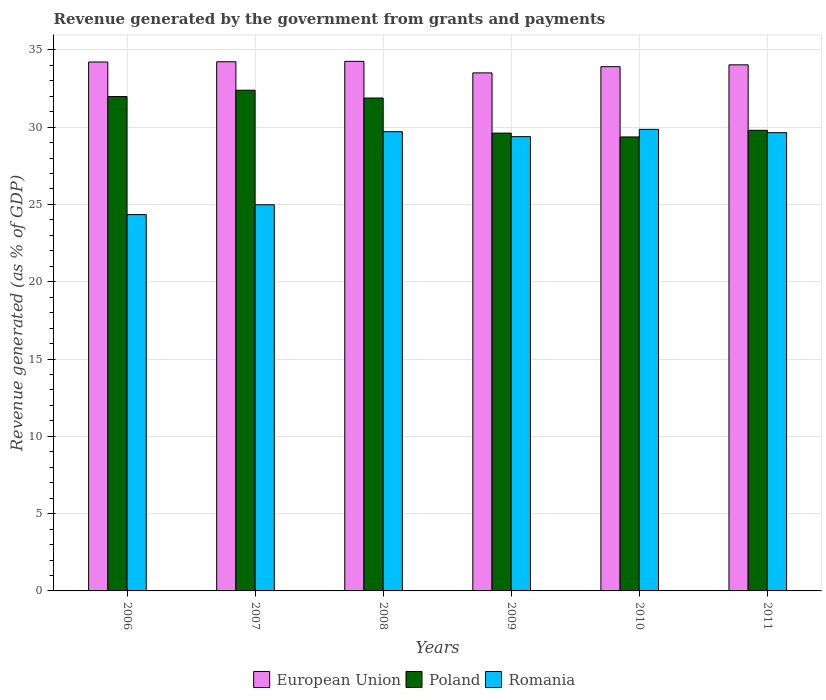Are the number of bars per tick equal to the number of legend labels?
Offer a very short reply. Yes. How many bars are there on the 3rd tick from the left?
Your response must be concise. 3. How many bars are there on the 4th tick from the right?
Give a very brief answer. 3. In how many cases, is the number of bars for a given year not equal to the number of legend labels?
Keep it short and to the point. 0. What is the revenue generated by the government in Romania in 2011?
Offer a very short reply. 29.64. Across all years, what is the maximum revenue generated by the government in Poland?
Your answer should be compact. 32.39. Across all years, what is the minimum revenue generated by the government in Romania?
Offer a terse response. 24.34. In which year was the revenue generated by the government in Romania minimum?
Provide a short and direct response. 2006. What is the total revenue generated by the government in Poland in the graph?
Offer a very short reply. 185.02. What is the difference between the revenue generated by the government in Romania in 2006 and that in 2009?
Your answer should be compact. -5.04. What is the difference between the revenue generated by the government in Romania in 2010 and the revenue generated by the government in Poland in 2009?
Offer a very short reply. 0.24. What is the average revenue generated by the government in European Union per year?
Offer a very short reply. 34.02. In the year 2009, what is the difference between the revenue generated by the government in Romania and revenue generated by the government in European Union?
Ensure brevity in your answer.  -4.13. In how many years, is the revenue generated by the government in Poland greater than 32 %?
Your answer should be very brief. 1. What is the ratio of the revenue generated by the government in European Union in 2009 to that in 2011?
Offer a very short reply. 0.98. What is the difference between the highest and the second highest revenue generated by the government in Romania?
Your answer should be very brief. 0.15. What is the difference between the highest and the lowest revenue generated by the government in Poland?
Offer a very short reply. 3.02. In how many years, is the revenue generated by the government in Romania greater than the average revenue generated by the government in Romania taken over all years?
Ensure brevity in your answer.  4. What does the 3rd bar from the left in 2006 represents?
Your response must be concise. Romania. Are all the bars in the graph horizontal?
Your answer should be very brief. No. What is the difference between two consecutive major ticks on the Y-axis?
Offer a terse response. 5. Does the graph contain any zero values?
Your answer should be very brief. No. Does the graph contain grids?
Your answer should be very brief. Yes. What is the title of the graph?
Offer a very short reply. Revenue generated by the government from grants and payments. What is the label or title of the Y-axis?
Ensure brevity in your answer.  Revenue generated (as % of GDP). What is the Revenue generated (as % of GDP) of European Union in 2006?
Provide a short and direct response. 34.21. What is the Revenue generated (as % of GDP) of Poland in 2006?
Offer a terse response. 31.98. What is the Revenue generated (as % of GDP) in Romania in 2006?
Your answer should be compact. 24.34. What is the Revenue generated (as % of GDP) of European Union in 2007?
Keep it short and to the point. 34.23. What is the Revenue generated (as % of GDP) of Poland in 2007?
Make the answer very short. 32.39. What is the Revenue generated (as % of GDP) in Romania in 2007?
Offer a very short reply. 24.98. What is the Revenue generated (as % of GDP) in European Union in 2008?
Provide a succinct answer. 34.25. What is the Revenue generated (as % of GDP) of Poland in 2008?
Keep it short and to the point. 31.88. What is the Revenue generated (as % of GDP) of Romania in 2008?
Offer a very short reply. 29.7. What is the Revenue generated (as % of GDP) of European Union in 2009?
Make the answer very short. 33.51. What is the Revenue generated (as % of GDP) of Poland in 2009?
Provide a succinct answer. 29.61. What is the Revenue generated (as % of GDP) in Romania in 2009?
Your response must be concise. 29.38. What is the Revenue generated (as % of GDP) in European Union in 2010?
Keep it short and to the point. 33.91. What is the Revenue generated (as % of GDP) of Poland in 2010?
Your answer should be very brief. 29.36. What is the Revenue generated (as % of GDP) of Romania in 2010?
Offer a terse response. 29.86. What is the Revenue generated (as % of GDP) in European Union in 2011?
Make the answer very short. 34.03. What is the Revenue generated (as % of GDP) in Poland in 2011?
Your answer should be very brief. 29.79. What is the Revenue generated (as % of GDP) of Romania in 2011?
Provide a succinct answer. 29.64. Across all years, what is the maximum Revenue generated (as % of GDP) in European Union?
Make the answer very short. 34.25. Across all years, what is the maximum Revenue generated (as % of GDP) in Poland?
Your response must be concise. 32.39. Across all years, what is the maximum Revenue generated (as % of GDP) in Romania?
Provide a short and direct response. 29.86. Across all years, what is the minimum Revenue generated (as % of GDP) of European Union?
Offer a terse response. 33.51. Across all years, what is the minimum Revenue generated (as % of GDP) in Poland?
Provide a short and direct response. 29.36. Across all years, what is the minimum Revenue generated (as % of GDP) of Romania?
Your answer should be compact. 24.34. What is the total Revenue generated (as % of GDP) in European Union in the graph?
Keep it short and to the point. 204.14. What is the total Revenue generated (as % of GDP) in Poland in the graph?
Provide a succinct answer. 185.02. What is the total Revenue generated (as % of GDP) in Romania in the graph?
Offer a terse response. 167.9. What is the difference between the Revenue generated (as % of GDP) of European Union in 2006 and that in 2007?
Provide a short and direct response. -0.02. What is the difference between the Revenue generated (as % of GDP) in Poland in 2006 and that in 2007?
Make the answer very short. -0.41. What is the difference between the Revenue generated (as % of GDP) of Romania in 2006 and that in 2007?
Provide a succinct answer. -0.64. What is the difference between the Revenue generated (as % of GDP) in European Union in 2006 and that in 2008?
Your response must be concise. -0.04. What is the difference between the Revenue generated (as % of GDP) of Poland in 2006 and that in 2008?
Offer a very short reply. 0.1. What is the difference between the Revenue generated (as % of GDP) in Romania in 2006 and that in 2008?
Your response must be concise. -5.36. What is the difference between the Revenue generated (as % of GDP) in European Union in 2006 and that in 2009?
Provide a succinct answer. 0.7. What is the difference between the Revenue generated (as % of GDP) of Poland in 2006 and that in 2009?
Offer a very short reply. 2.36. What is the difference between the Revenue generated (as % of GDP) of Romania in 2006 and that in 2009?
Your response must be concise. -5.04. What is the difference between the Revenue generated (as % of GDP) in European Union in 2006 and that in 2010?
Ensure brevity in your answer.  0.3. What is the difference between the Revenue generated (as % of GDP) of Poland in 2006 and that in 2010?
Give a very brief answer. 2.61. What is the difference between the Revenue generated (as % of GDP) in Romania in 2006 and that in 2010?
Your answer should be very brief. -5.51. What is the difference between the Revenue generated (as % of GDP) of European Union in 2006 and that in 2011?
Ensure brevity in your answer.  0.18. What is the difference between the Revenue generated (as % of GDP) in Poland in 2006 and that in 2011?
Give a very brief answer. 2.18. What is the difference between the Revenue generated (as % of GDP) of Romania in 2006 and that in 2011?
Provide a succinct answer. -5.3. What is the difference between the Revenue generated (as % of GDP) of European Union in 2007 and that in 2008?
Offer a terse response. -0.03. What is the difference between the Revenue generated (as % of GDP) in Poland in 2007 and that in 2008?
Your answer should be compact. 0.51. What is the difference between the Revenue generated (as % of GDP) in Romania in 2007 and that in 2008?
Offer a very short reply. -4.72. What is the difference between the Revenue generated (as % of GDP) of European Union in 2007 and that in 2009?
Offer a very short reply. 0.72. What is the difference between the Revenue generated (as % of GDP) of Poland in 2007 and that in 2009?
Make the answer very short. 2.78. What is the difference between the Revenue generated (as % of GDP) in Romania in 2007 and that in 2009?
Ensure brevity in your answer.  -4.4. What is the difference between the Revenue generated (as % of GDP) of European Union in 2007 and that in 2010?
Offer a very short reply. 0.32. What is the difference between the Revenue generated (as % of GDP) in Poland in 2007 and that in 2010?
Provide a succinct answer. 3.02. What is the difference between the Revenue generated (as % of GDP) in Romania in 2007 and that in 2010?
Provide a short and direct response. -4.88. What is the difference between the Revenue generated (as % of GDP) in European Union in 2007 and that in 2011?
Offer a terse response. 0.2. What is the difference between the Revenue generated (as % of GDP) of Poland in 2007 and that in 2011?
Provide a short and direct response. 2.59. What is the difference between the Revenue generated (as % of GDP) in Romania in 2007 and that in 2011?
Your response must be concise. -4.66. What is the difference between the Revenue generated (as % of GDP) in European Union in 2008 and that in 2009?
Your response must be concise. 0.75. What is the difference between the Revenue generated (as % of GDP) of Poland in 2008 and that in 2009?
Your answer should be very brief. 2.27. What is the difference between the Revenue generated (as % of GDP) of Romania in 2008 and that in 2009?
Your answer should be very brief. 0.32. What is the difference between the Revenue generated (as % of GDP) of European Union in 2008 and that in 2010?
Provide a short and direct response. 0.34. What is the difference between the Revenue generated (as % of GDP) of Poland in 2008 and that in 2010?
Provide a succinct answer. 2.52. What is the difference between the Revenue generated (as % of GDP) in Romania in 2008 and that in 2010?
Your response must be concise. -0.15. What is the difference between the Revenue generated (as % of GDP) of European Union in 2008 and that in 2011?
Keep it short and to the point. 0.23. What is the difference between the Revenue generated (as % of GDP) in Poland in 2008 and that in 2011?
Keep it short and to the point. 2.09. What is the difference between the Revenue generated (as % of GDP) in Romania in 2008 and that in 2011?
Provide a short and direct response. 0.06. What is the difference between the Revenue generated (as % of GDP) of European Union in 2009 and that in 2010?
Offer a very short reply. -0.4. What is the difference between the Revenue generated (as % of GDP) of Poland in 2009 and that in 2010?
Give a very brief answer. 0.25. What is the difference between the Revenue generated (as % of GDP) in Romania in 2009 and that in 2010?
Provide a succinct answer. -0.47. What is the difference between the Revenue generated (as % of GDP) in European Union in 2009 and that in 2011?
Provide a succinct answer. -0.52. What is the difference between the Revenue generated (as % of GDP) in Poland in 2009 and that in 2011?
Offer a terse response. -0.18. What is the difference between the Revenue generated (as % of GDP) of Romania in 2009 and that in 2011?
Ensure brevity in your answer.  -0.26. What is the difference between the Revenue generated (as % of GDP) in European Union in 2010 and that in 2011?
Ensure brevity in your answer.  -0.12. What is the difference between the Revenue generated (as % of GDP) in Poland in 2010 and that in 2011?
Your response must be concise. -0.43. What is the difference between the Revenue generated (as % of GDP) of Romania in 2010 and that in 2011?
Give a very brief answer. 0.21. What is the difference between the Revenue generated (as % of GDP) in European Union in 2006 and the Revenue generated (as % of GDP) in Poland in 2007?
Offer a very short reply. 1.82. What is the difference between the Revenue generated (as % of GDP) of European Union in 2006 and the Revenue generated (as % of GDP) of Romania in 2007?
Keep it short and to the point. 9.23. What is the difference between the Revenue generated (as % of GDP) in Poland in 2006 and the Revenue generated (as % of GDP) in Romania in 2007?
Offer a terse response. 7. What is the difference between the Revenue generated (as % of GDP) in European Union in 2006 and the Revenue generated (as % of GDP) in Poland in 2008?
Offer a terse response. 2.33. What is the difference between the Revenue generated (as % of GDP) in European Union in 2006 and the Revenue generated (as % of GDP) in Romania in 2008?
Your answer should be compact. 4.51. What is the difference between the Revenue generated (as % of GDP) of Poland in 2006 and the Revenue generated (as % of GDP) of Romania in 2008?
Offer a very short reply. 2.27. What is the difference between the Revenue generated (as % of GDP) in European Union in 2006 and the Revenue generated (as % of GDP) in Poland in 2009?
Offer a very short reply. 4.6. What is the difference between the Revenue generated (as % of GDP) of European Union in 2006 and the Revenue generated (as % of GDP) of Romania in 2009?
Your answer should be very brief. 4.83. What is the difference between the Revenue generated (as % of GDP) in Poland in 2006 and the Revenue generated (as % of GDP) in Romania in 2009?
Offer a terse response. 2.59. What is the difference between the Revenue generated (as % of GDP) in European Union in 2006 and the Revenue generated (as % of GDP) in Poland in 2010?
Provide a succinct answer. 4.85. What is the difference between the Revenue generated (as % of GDP) in European Union in 2006 and the Revenue generated (as % of GDP) in Romania in 2010?
Your answer should be compact. 4.36. What is the difference between the Revenue generated (as % of GDP) in Poland in 2006 and the Revenue generated (as % of GDP) in Romania in 2010?
Make the answer very short. 2.12. What is the difference between the Revenue generated (as % of GDP) of European Union in 2006 and the Revenue generated (as % of GDP) of Poland in 2011?
Keep it short and to the point. 4.42. What is the difference between the Revenue generated (as % of GDP) of European Union in 2006 and the Revenue generated (as % of GDP) of Romania in 2011?
Your response must be concise. 4.57. What is the difference between the Revenue generated (as % of GDP) in Poland in 2006 and the Revenue generated (as % of GDP) in Romania in 2011?
Your response must be concise. 2.34. What is the difference between the Revenue generated (as % of GDP) of European Union in 2007 and the Revenue generated (as % of GDP) of Poland in 2008?
Keep it short and to the point. 2.35. What is the difference between the Revenue generated (as % of GDP) of European Union in 2007 and the Revenue generated (as % of GDP) of Romania in 2008?
Provide a succinct answer. 4.53. What is the difference between the Revenue generated (as % of GDP) in Poland in 2007 and the Revenue generated (as % of GDP) in Romania in 2008?
Provide a short and direct response. 2.69. What is the difference between the Revenue generated (as % of GDP) in European Union in 2007 and the Revenue generated (as % of GDP) in Poland in 2009?
Make the answer very short. 4.62. What is the difference between the Revenue generated (as % of GDP) in European Union in 2007 and the Revenue generated (as % of GDP) in Romania in 2009?
Provide a succinct answer. 4.85. What is the difference between the Revenue generated (as % of GDP) of Poland in 2007 and the Revenue generated (as % of GDP) of Romania in 2009?
Give a very brief answer. 3.01. What is the difference between the Revenue generated (as % of GDP) of European Union in 2007 and the Revenue generated (as % of GDP) of Poland in 2010?
Your answer should be compact. 4.86. What is the difference between the Revenue generated (as % of GDP) of European Union in 2007 and the Revenue generated (as % of GDP) of Romania in 2010?
Make the answer very short. 4.37. What is the difference between the Revenue generated (as % of GDP) in Poland in 2007 and the Revenue generated (as % of GDP) in Romania in 2010?
Provide a succinct answer. 2.53. What is the difference between the Revenue generated (as % of GDP) in European Union in 2007 and the Revenue generated (as % of GDP) in Poland in 2011?
Keep it short and to the point. 4.43. What is the difference between the Revenue generated (as % of GDP) in European Union in 2007 and the Revenue generated (as % of GDP) in Romania in 2011?
Offer a very short reply. 4.59. What is the difference between the Revenue generated (as % of GDP) of Poland in 2007 and the Revenue generated (as % of GDP) of Romania in 2011?
Your answer should be compact. 2.75. What is the difference between the Revenue generated (as % of GDP) of European Union in 2008 and the Revenue generated (as % of GDP) of Poland in 2009?
Provide a short and direct response. 4.64. What is the difference between the Revenue generated (as % of GDP) of European Union in 2008 and the Revenue generated (as % of GDP) of Romania in 2009?
Offer a very short reply. 4.87. What is the difference between the Revenue generated (as % of GDP) in Poland in 2008 and the Revenue generated (as % of GDP) in Romania in 2009?
Provide a short and direct response. 2.5. What is the difference between the Revenue generated (as % of GDP) of European Union in 2008 and the Revenue generated (as % of GDP) of Poland in 2010?
Ensure brevity in your answer.  4.89. What is the difference between the Revenue generated (as % of GDP) of European Union in 2008 and the Revenue generated (as % of GDP) of Romania in 2010?
Make the answer very short. 4.4. What is the difference between the Revenue generated (as % of GDP) in Poland in 2008 and the Revenue generated (as % of GDP) in Romania in 2010?
Keep it short and to the point. 2.03. What is the difference between the Revenue generated (as % of GDP) of European Union in 2008 and the Revenue generated (as % of GDP) of Poland in 2011?
Provide a short and direct response. 4.46. What is the difference between the Revenue generated (as % of GDP) of European Union in 2008 and the Revenue generated (as % of GDP) of Romania in 2011?
Provide a short and direct response. 4.61. What is the difference between the Revenue generated (as % of GDP) of Poland in 2008 and the Revenue generated (as % of GDP) of Romania in 2011?
Your answer should be very brief. 2.24. What is the difference between the Revenue generated (as % of GDP) of European Union in 2009 and the Revenue generated (as % of GDP) of Poland in 2010?
Offer a very short reply. 4.14. What is the difference between the Revenue generated (as % of GDP) in European Union in 2009 and the Revenue generated (as % of GDP) in Romania in 2010?
Provide a succinct answer. 3.65. What is the difference between the Revenue generated (as % of GDP) in Poland in 2009 and the Revenue generated (as % of GDP) in Romania in 2010?
Your response must be concise. -0.24. What is the difference between the Revenue generated (as % of GDP) in European Union in 2009 and the Revenue generated (as % of GDP) in Poland in 2011?
Give a very brief answer. 3.71. What is the difference between the Revenue generated (as % of GDP) in European Union in 2009 and the Revenue generated (as % of GDP) in Romania in 2011?
Offer a very short reply. 3.87. What is the difference between the Revenue generated (as % of GDP) of Poland in 2009 and the Revenue generated (as % of GDP) of Romania in 2011?
Your response must be concise. -0.03. What is the difference between the Revenue generated (as % of GDP) in European Union in 2010 and the Revenue generated (as % of GDP) in Poland in 2011?
Offer a terse response. 4.12. What is the difference between the Revenue generated (as % of GDP) in European Union in 2010 and the Revenue generated (as % of GDP) in Romania in 2011?
Your answer should be compact. 4.27. What is the difference between the Revenue generated (as % of GDP) of Poland in 2010 and the Revenue generated (as % of GDP) of Romania in 2011?
Offer a terse response. -0.28. What is the average Revenue generated (as % of GDP) in European Union per year?
Your answer should be compact. 34.02. What is the average Revenue generated (as % of GDP) of Poland per year?
Make the answer very short. 30.84. What is the average Revenue generated (as % of GDP) of Romania per year?
Your answer should be compact. 27.98. In the year 2006, what is the difference between the Revenue generated (as % of GDP) in European Union and Revenue generated (as % of GDP) in Poland?
Your response must be concise. 2.24. In the year 2006, what is the difference between the Revenue generated (as % of GDP) of European Union and Revenue generated (as % of GDP) of Romania?
Give a very brief answer. 9.87. In the year 2006, what is the difference between the Revenue generated (as % of GDP) in Poland and Revenue generated (as % of GDP) in Romania?
Provide a succinct answer. 7.64. In the year 2007, what is the difference between the Revenue generated (as % of GDP) in European Union and Revenue generated (as % of GDP) in Poland?
Provide a succinct answer. 1.84. In the year 2007, what is the difference between the Revenue generated (as % of GDP) of European Union and Revenue generated (as % of GDP) of Romania?
Provide a short and direct response. 9.25. In the year 2007, what is the difference between the Revenue generated (as % of GDP) in Poland and Revenue generated (as % of GDP) in Romania?
Give a very brief answer. 7.41. In the year 2008, what is the difference between the Revenue generated (as % of GDP) of European Union and Revenue generated (as % of GDP) of Poland?
Offer a very short reply. 2.37. In the year 2008, what is the difference between the Revenue generated (as % of GDP) of European Union and Revenue generated (as % of GDP) of Romania?
Your answer should be very brief. 4.55. In the year 2008, what is the difference between the Revenue generated (as % of GDP) in Poland and Revenue generated (as % of GDP) in Romania?
Provide a short and direct response. 2.18. In the year 2009, what is the difference between the Revenue generated (as % of GDP) in European Union and Revenue generated (as % of GDP) in Poland?
Provide a short and direct response. 3.9. In the year 2009, what is the difference between the Revenue generated (as % of GDP) of European Union and Revenue generated (as % of GDP) of Romania?
Your answer should be very brief. 4.13. In the year 2009, what is the difference between the Revenue generated (as % of GDP) in Poland and Revenue generated (as % of GDP) in Romania?
Ensure brevity in your answer.  0.23. In the year 2010, what is the difference between the Revenue generated (as % of GDP) of European Union and Revenue generated (as % of GDP) of Poland?
Offer a terse response. 4.55. In the year 2010, what is the difference between the Revenue generated (as % of GDP) of European Union and Revenue generated (as % of GDP) of Romania?
Make the answer very short. 4.05. In the year 2010, what is the difference between the Revenue generated (as % of GDP) of Poland and Revenue generated (as % of GDP) of Romania?
Keep it short and to the point. -0.49. In the year 2011, what is the difference between the Revenue generated (as % of GDP) in European Union and Revenue generated (as % of GDP) in Poland?
Your response must be concise. 4.23. In the year 2011, what is the difference between the Revenue generated (as % of GDP) in European Union and Revenue generated (as % of GDP) in Romania?
Your answer should be compact. 4.39. In the year 2011, what is the difference between the Revenue generated (as % of GDP) of Poland and Revenue generated (as % of GDP) of Romania?
Provide a succinct answer. 0.15. What is the ratio of the Revenue generated (as % of GDP) in Poland in 2006 to that in 2007?
Your response must be concise. 0.99. What is the ratio of the Revenue generated (as % of GDP) of Romania in 2006 to that in 2007?
Ensure brevity in your answer.  0.97. What is the ratio of the Revenue generated (as % of GDP) of European Union in 2006 to that in 2008?
Make the answer very short. 1. What is the ratio of the Revenue generated (as % of GDP) of Poland in 2006 to that in 2008?
Offer a very short reply. 1. What is the ratio of the Revenue generated (as % of GDP) of Romania in 2006 to that in 2008?
Make the answer very short. 0.82. What is the ratio of the Revenue generated (as % of GDP) of European Union in 2006 to that in 2009?
Give a very brief answer. 1.02. What is the ratio of the Revenue generated (as % of GDP) of Poland in 2006 to that in 2009?
Keep it short and to the point. 1.08. What is the ratio of the Revenue generated (as % of GDP) in Romania in 2006 to that in 2009?
Ensure brevity in your answer.  0.83. What is the ratio of the Revenue generated (as % of GDP) in European Union in 2006 to that in 2010?
Offer a very short reply. 1.01. What is the ratio of the Revenue generated (as % of GDP) in Poland in 2006 to that in 2010?
Offer a terse response. 1.09. What is the ratio of the Revenue generated (as % of GDP) of Romania in 2006 to that in 2010?
Your answer should be very brief. 0.82. What is the ratio of the Revenue generated (as % of GDP) in European Union in 2006 to that in 2011?
Offer a terse response. 1.01. What is the ratio of the Revenue generated (as % of GDP) in Poland in 2006 to that in 2011?
Provide a succinct answer. 1.07. What is the ratio of the Revenue generated (as % of GDP) of Romania in 2006 to that in 2011?
Keep it short and to the point. 0.82. What is the ratio of the Revenue generated (as % of GDP) of European Union in 2007 to that in 2008?
Your answer should be very brief. 1. What is the ratio of the Revenue generated (as % of GDP) in Poland in 2007 to that in 2008?
Offer a very short reply. 1.02. What is the ratio of the Revenue generated (as % of GDP) of Romania in 2007 to that in 2008?
Provide a short and direct response. 0.84. What is the ratio of the Revenue generated (as % of GDP) of European Union in 2007 to that in 2009?
Offer a terse response. 1.02. What is the ratio of the Revenue generated (as % of GDP) in Poland in 2007 to that in 2009?
Your response must be concise. 1.09. What is the ratio of the Revenue generated (as % of GDP) of Romania in 2007 to that in 2009?
Give a very brief answer. 0.85. What is the ratio of the Revenue generated (as % of GDP) of European Union in 2007 to that in 2010?
Your answer should be very brief. 1.01. What is the ratio of the Revenue generated (as % of GDP) in Poland in 2007 to that in 2010?
Give a very brief answer. 1.1. What is the ratio of the Revenue generated (as % of GDP) in Romania in 2007 to that in 2010?
Keep it short and to the point. 0.84. What is the ratio of the Revenue generated (as % of GDP) in Poland in 2007 to that in 2011?
Offer a very short reply. 1.09. What is the ratio of the Revenue generated (as % of GDP) in Romania in 2007 to that in 2011?
Your response must be concise. 0.84. What is the ratio of the Revenue generated (as % of GDP) in European Union in 2008 to that in 2009?
Ensure brevity in your answer.  1.02. What is the ratio of the Revenue generated (as % of GDP) of Poland in 2008 to that in 2009?
Ensure brevity in your answer.  1.08. What is the ratio of the Revenue generated (as % of GDP) of Romania in 2008 to that in 2009?
Keep it short and to the point. 1.01. What is the ratio of the Revenue generated (as % of GDP) of European Union in 2008 to that in 2010?
Your answer should be very brief. 1.01. What is the ratio of the Revenue generated (as % of GDP) in Poland in 2008 to that in 2010?
Provide a short and direct response. 1.09. What is the ratio of the Revenue generated (as % of GDP) in Romania in 2008 to that in 2010?
Your response must be concise. 0.99. What is the ratio of the Revenue generated (as % of GDP) in European Union in 2008 to that in 2011?
Offer a very short reply. 1.01. What is the ratio of the Revenue generated (as % of GDP) in Poland in 2008 to that in 2011?
Offer a very short reply. 1.07. What is the ratio of the Revenue generated (as % of GDP) in European Union in 2009 to that in 2010?
Your answer should be very brief. 0.99. What is the ratio of the Revenue generated (as % of GDP) of Poland in 2009 to that in 2010?
Provide a short and direct response. 1.01. What is the ratio of the Revenue generated (as % of GDP) of Romania in 2009 to that in 2010?
Offer a very short reply. 0.98. What is the ratio of the Revenue generated (as % of GDP) of European Union in 2009 to that in 2011?
Give a very brief answer. 0.98. What is the ratio of the Revenue generated (as % of GDP) of Poland in 2009 to that in 2011?
Ensure brevity in your answer.  0.99. What is the ratio of the Revenue generated (as % of GDP) of Romania in 2009 to that in 2011?
Keep it short and to the point. 0.99. What is the ratio of the Revenue generated (as % of GDP) in European Union in 2010 to that in 2011?
Offer a terse response. 1. What is the ratio of the Revenue generated (as % of GDP) of Poland in 2010 to that in 2011?
Make the answer very short. 0.99. What is the difference between the highest and the second highest Revenue generated (as % of GDP) in European Union?
Provide a succinct answer. 0.03. What is the difference between the highest and the second highest Revenue generated (as % of GDP) in Poland?
Offer a terse response. 0.41. What is the difference between the highest and the second highest Revenue generated (as % of GDP) in Romania?
Your response must be concise. 0.15. What is the difference between the highest and the lowest Revenue generated (as % of GDP) of European Union?
Make the answer very short. 0.75. What is the difference between the highest and the lowest Revenue generated (as % of GDP) in Poland?
Provide a short and direct response. 3.02. What is the difference between the highest and the lowest Revenue generated (as % of GDP) in Romania?
Offer a very short reply. 5.51. 